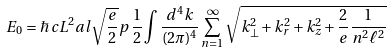Convert formula to latex. <formula><loc_0><loc_0><loc_500><loc_500>E _ { 0 } = \hbar { \, } c L ^ { 2 } a l \sqrt { \frac { e } { 2 } } p \, \frac { 1 } { 2 } \int \frac { d ^ { 4 } k } { ( 2 \pi ) ^ { 4 } } \sum _ { n = 1 } ^ { \infty } \sqrt { k _ { \perp } ^ { 2 } + k _ { r } ^ { 2 } + k _ { z } ^ { 2 } + \frac { 2 } { e } \frac { 1 } { n ^ { 2 } \ell ^ { 2 } } }</formula> 